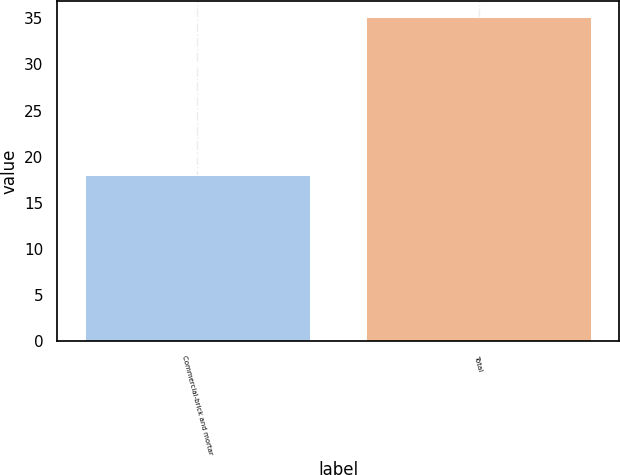Convert chart. <chart><loc_0><loc_0><loc_500><loc_500><bar_chart><fcel>Commercial-brick and mortar<fcel>Total<nl><fcel>18<fcel>35.1<nl></chart> 